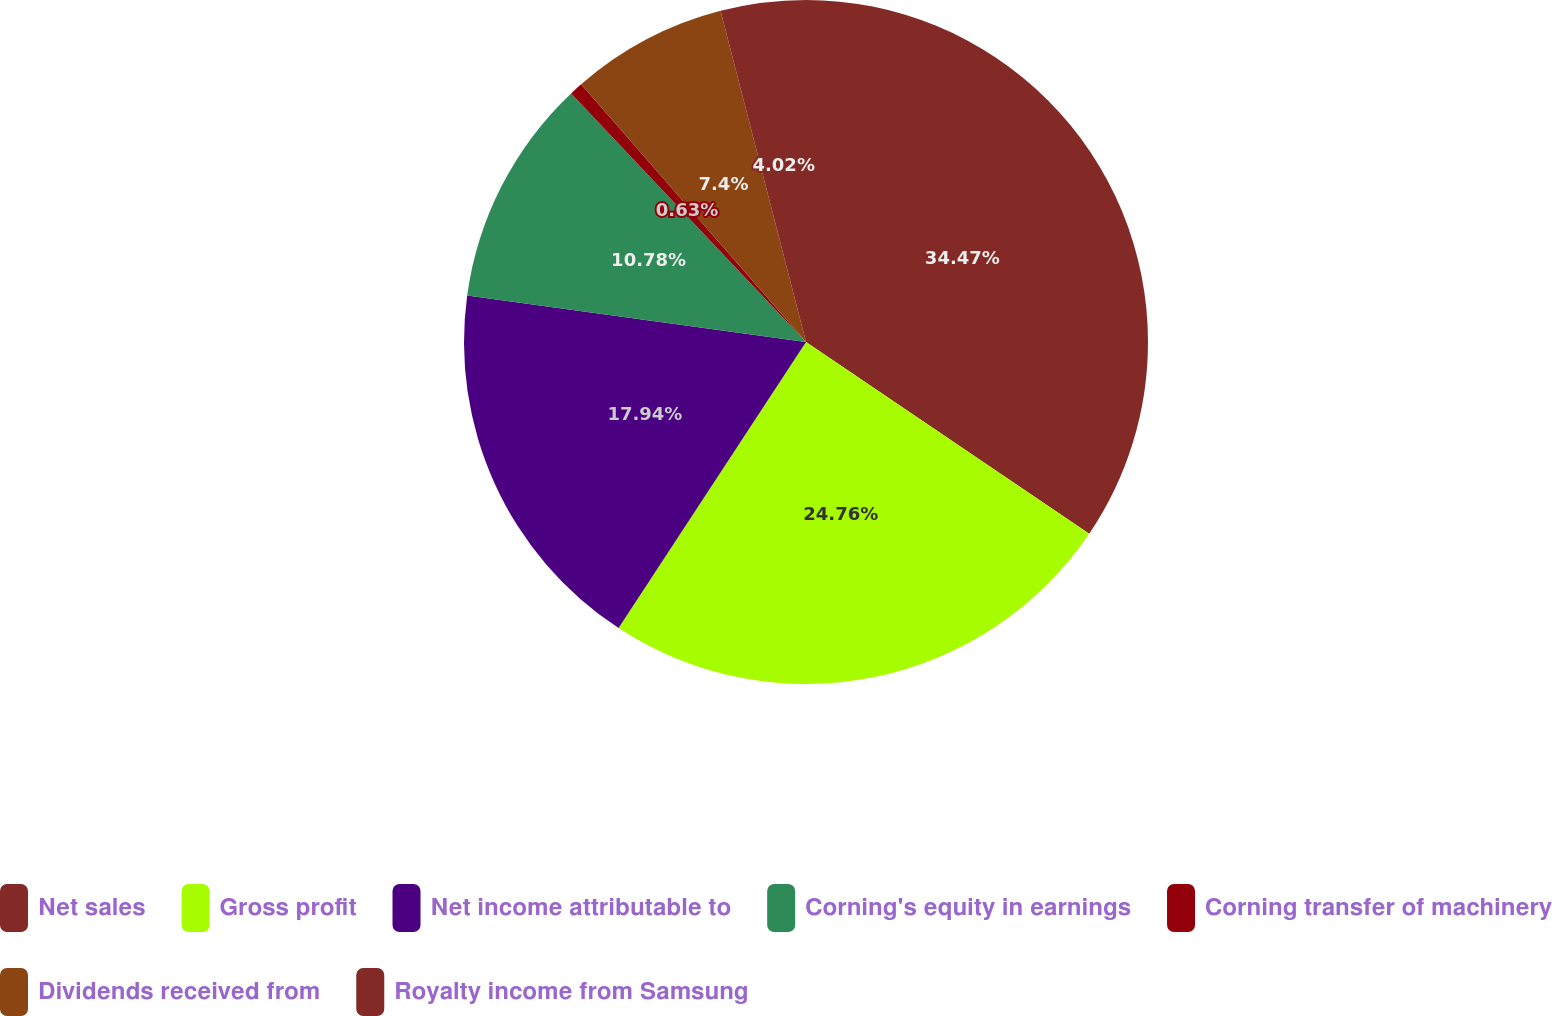Convert chart to OTSL. <chart><loc_0><loc_0><loc_500><loc_500><pie_chart><fcel>Net sales<fcel>Gross profit<fcel>Net income attributable to<fcel>Corning's equity in earnings<fcel>Corning transfer of machinery<fcel>Dividends received from<fcel>Royalty income from Samsung<nl><fcel>34.47%<fcel>24.76%<fcel>17.94%<fcel>10.78%<fcel>0.63%<fcel>7.4%<fcel>4.02%<nl></chart> 